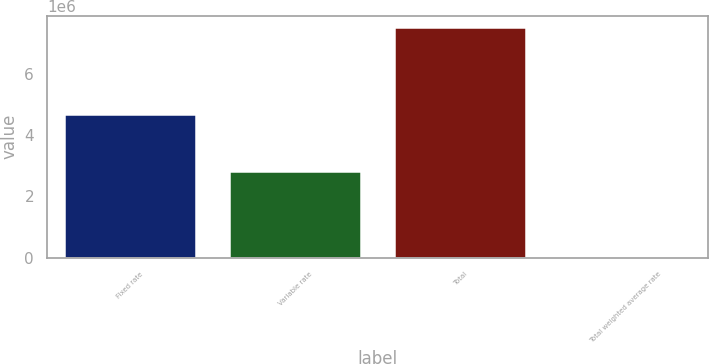Convert chart. <chart><loc_0><loc_0><loc_500><loc_500><bar_chart><fcel>Fixed rate<fcel>Variable rate<fcel>Total<fcel>Total weighted average rate<nl><fcel>4.70499e+06<fcel>2.82232e+06<fcel>7.5273e+06<fcel>6.08<nl></chart> 